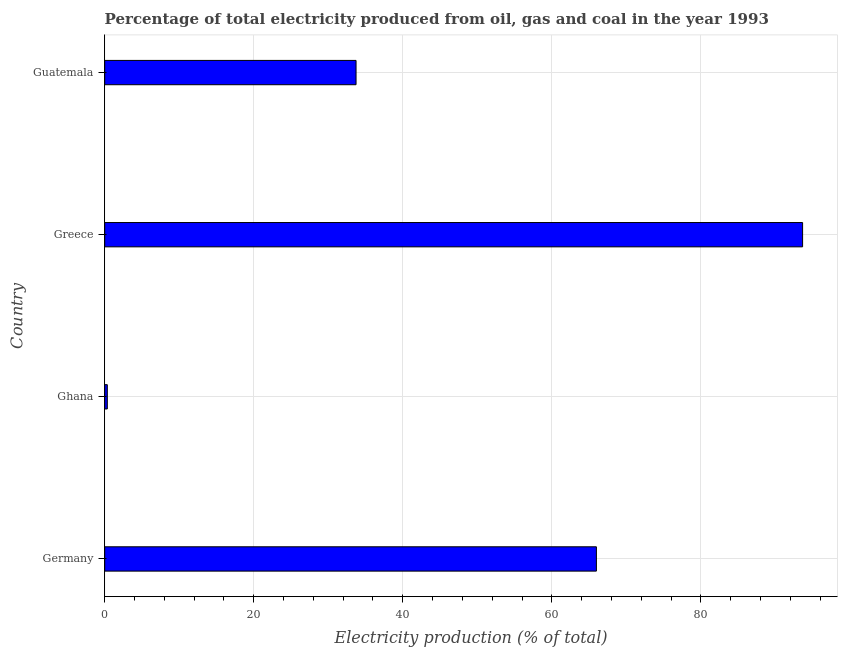Does the graph contain any zero values?
Keep it short and to the point. No. What is the title of the graph?
Your response must be concise. Percentage of total electricity produced from oil, gas and coal in the year 1993. What is the label or title of the X-axis?
Give a very brief answer. Electricity production (% of total). What is the label or title of the Y-axis?
Keep it short and to the point. Country. What is the electricity production in Guatemala?
Your answer should be very brief. 33.73. Across all countries, what is the maximum electricity production?
Your answer should be very brief. 93.65. Across all countries, what is the minimum electricity production?
Ensure brevity in your answer.  0.35. In which country was the electricity production minimum?
Ensure brevity in your answer.  Ghana. What is the sum of the electricity production?
Make the answer very short. 193.71. What is the difference between the electricity production in Germany and Greece?
Offer a terse response. -27.67. What is the average electricity production per country?
Provide a succinct answer. 48.43. What is the median electricity production?
Provide a succinct answer. 49.85. In how many countries, is the electricity production greater than 20 %?
Your answer should be compact. 3. What is the ratio of the electricity production in Germany to that in Greece?
Give a very brief answer. 0.7. Is the electricity production in Ghana less than that in Greece?
Keep it short and to the point. Yes. What is the difference between the highest and the second highest electricity production?
Ensure brevity in your answer.  27.67. Is the sum of the electricity production in Ghana and Greece greater than the maximum electricity production across all countries?
Provide a short and direct response. Yes. What is the difference between the highest and the lowest electricity production?
Provide a succinct answer. 93.3. In how many countries, is the electricity production greater than the average electricity production taken over all countries?
Provide a short and direct response. 2. How many bars are there?
Make the answer very short. 4. Are all the bars in the graph horizontal?
Your answer should be compact. Yes. How many countries are there in the graph?
Offer a very short reply. 4. Are the values on the major ticks of X-axis written in scientific E-notation?
Give a very brief answer. No. What is the Electricity production (% of total) in Germany?
Offer a very short reply. 65.98. What is the Electricity production (% of total) in Ghana?
Provide a short and direct response. 0.35. What is the Electricity production (% of total) of Greece?
Keep it short and to the point. 93.65. What is the Electricity production (% of total) of Guatemala?
Your answer should be very brief. 33.73. What is the difference between the Electricity production (% of total) in Germany and Ghana?
Give a very brief answer. 65.63. What is the difference between the Electricity production (% of total) in Germany and Greece?
Offer a very short reply. -27.67. What is the difference between the Electricity production (% of total) in Germany and Guatemala?
Offer a terse response. 32.25. What is the difference between the Electricity production (% of total) in Ghana and Greece?
Provide a short and direct response. -93.3. What is the difference between the Electricity production (% of total) in Ghana and Guatemala?
Your answer should be very brief. -33.38. What is the difference between the Electricity production (% of total) in Greece and Guatemala?
Give a very brief answer. 59.92. What is the ratio of the Electricity production (% of total) in Germany to that in Ghana?
Provide a short and direct response. 189.34. What is the ratio of the Electricity production (% of total) in Germany to that in Greece?
Keep it short and to the point. 0.7. What is the ratio of the Electricity production (% of total) in Germany to that in Guatemala?
Provide a short and direct response. 1.96. What is the ratio of the Electricity production (% of total) in Ghana to that in Greece?
Your answer should be compact. 0. What is the ratio of the Electricity production (% of total) in Greece to that in Guatemala?
Make the answer very short. 2.78. 